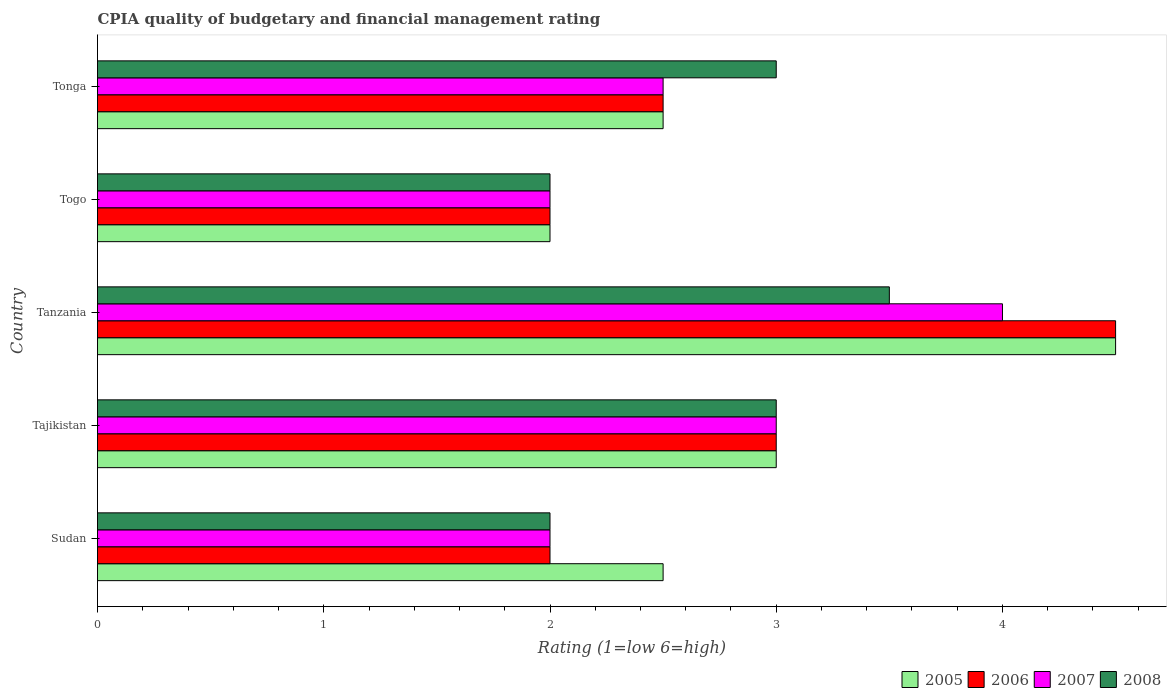How many different coloured bars are there?
Provide a succinct answer. 4. How many groups of bars are there?
Provide a short and direct response. 5. Are the number of bars on each tick of the Y-axis equal?
Provide a short and direct response. Yes. How many bars are there on the 4th tick from the bottom?
Offer a terse response. 4. What is the label of the 4th group of bars from the top?
Offer a terse response. Tajikistan. In how many cases, is the number of bars for a given country not equal to the number of legend labels?
Provide a succinct answer. 0. Across all countries, what is the maximum CPIA rating in 2005?
Your answer should be compact. 4.5. In which country was the CPIA rating in 2006 maximum?
Keep it short and to the point. Tanzania. In which country was the CPIA rating in 2005 minimum?
Ensure brevity in your answer.  Togo. What is the difference between the CPIA rating in 2005 in Sudan and that in Tanzania?
Ensure brevity in your answer.  -2. What is the difference between the CPIA rating in 2008 in Togo and the CPIA rating in 2006 in Tonga?
Ensure brevity in your answer.  -0.5. What is the difference between the CPIA rating in 2008 and CPIA rating in 2005 in Tonga?
Provide a short and direct response. 0.5. Is the CPIA rating in 2006 in Togo less than that in Tonga?
Give a very brief answer. Yes. Is the difference between the CPIA rating in 2008 in Sudan and Tajikistan greater than the difference between the CPIA rating in 2005 in Sudan and Tajikistan?
Your answer should be compact. No. In how many countries, is the CPIA rating in 2005 greater than the average CPIA rating in 2005 taken over all countries?
Offer a terse response. 2. Is the sum of the CPIA rating in 2005 in Tajikistan and Tonga greater than the maximum CPIA rating in 2006 across all countries?
Offer a terse response. Yes. Is it the case that in every country, the sum of the CPIA rating in 2005 and CPIA rating in 2008 is greater than the sum of CPIA rating in 2007 and CPIA rating in 2006?
Provide a succinct answer. No. Is it the case that in every country, the sum of the CPIA rating in 2007 and CPIA rating in 2005 is greater than the CPIA rating in 2008?
Offer a very short reply. Yes. How many countries are there in the graph?
Your answer should be very brief. 5. Does the graph contain grids?
Provide a short and direct response. No. Where does the legend appear in the graph?
Make the answer very short. Bottom right. How are the legend labels stacked?
Ensure brevity in your answer.  Horizontal. What is the title of the graph?
Make the answer very short. CPIA quality of budgetary and financial management rating. What is the label or title of the X-axis?
Ensure brevity in your answer.  Rating (1=low 6=high). What is the Rating (1=low 6=high) in 2005 in Sudan?
Provide a short and direct response. 2.5. What is the Rating (1=low 6=high) of 2006 in Sudan?
Your answer should be very brief. 2. What is the Rating (1=low 6=high) of 2007 in Sudan?
Offer a very short reply. 2. What is the Rating (1=low 6=high) in 2008 in Sudan?
Offer a terse response. 2. What is the Rating (1=low 6=high) of 2008 in Tanzania?
Give a very brief answer. 3.5. What is the Rating (1=low 6=high) in 2006 in Togo?
Offer a terse response. 2. What is the Rating (1=low 6=high) of 2008 in Togo?
Offer a terse response. 2. What is the Rating (1=low 6=high) in 2006 in Tonga?
Provide a succinct answer. 2.5. What is the Rating (1=low 6=high) of 2007 in Tonga?
Offer a terse response. 2.5. Across all countries, what is the maximum Rating (1=low 6=high) in 2007?
Offer a very short reply. 4. Across all countries, what is the maximum Rating (1=low 6=high) in 2008?
Ensure brevity in your answer.  3.5. Across all countries, what is the minimum Rating (1=low 6=high) in 2006?
Provide a short and direct response. 2. Across all countries, what is the minimum Rating (1=low 6=high) of 2007?
Your response must be concise. 2. What is the total Rating (1=low 6=high) of 2006 in the graph?
Give a very brief answer. 14. What is the total Rating (1=low 6=high) of 2008 in the graph?
Offer a very short reply. 13.5. What is the difference between the Rating (1=low 6=high) in 2005 in Sudan and that in Tajikistan?
Keep it short and to the point. -0.5. What is the difference between the Rating (1=low 6=high) of 2006 in Sudan and that in Tajikistan?
Give a very brief answer. -1. What is the difference between the Rating (1=low 6=high) of 2007 in Sudan and that in Tajikistan?
Your answer should be very brief. -1. What is the difference between the Rating (1=low 6=high) in 2006 in Sudan and that in Tanzania?
Offer a terse response. -2.5. What is the difference between the Rating (1=low 6=high) in 2005 in Sudan and that in Togo?
Give a very brief answer. 0.5. What is the difference between the Rating (1=low 6=high) in 2006 in Sudan and that in Togo?
Ensure brevity in your answer.  0. What is the difference between the Rating (1=low 6=high) in 2008 in Sudan and that in Togo?
Your answer should be very brief. 0. What is the difference between the Rating (1=low 6=high) of 2007 in Sudan and that in Tonga?
Offer a very short reply. -0.5. What is the difference between the Rating (1=low 6=high) in 2008 in Sudan and that in Tonga?
Give a very brief answer. -1. What is the difference between the Rating (1=low 6=high) of 2005 in Tajikistan and that in Tanzania?
Provide a succinct answer. -1.5. What is the difference between the Rating (1=low 6=high) of 2006 in Tajikistan and that in Tanzania?
Provide a succinct answer. -1.5. What is the difference between the Rating (1=low 6=high) in 2007 in Tajikistan and that in Tanzania?
Ensure brevity in your answer.  -1. What is the difference between the Rating (1=low 6=high) in 2005 in Tajikistan and that in Togo?
Your answer should be very brief. 1. What is the difference between the Rating (1=low 6=high) in 2006 in Tajikistan and that in Togo?
Your response must be concise. 1. What is the difference between the Rating (1=low 6=high) of 2008 in Tajikistan and that in Togo?
Give a very brief answer. 1. What is the difference between the Rating (1=low 6=high) in 2007 in Tajikistan and that in Tonga?
Provide a short and direct response. 0.5. What is the difference between the Rating (1=low 6=high) of 2007 in Tanzania and that in Togo?
Your answer should be compact. 2. What is the difference between the Rating (1=low 6=high) of 2008 in Tanzania and that in Togo?
Give a very brief answer. 1.5. What is the difference between the Rating (1=low 6=high) of 2006 in Tanzania and that in Tonga?
Your response must be concise. 2. What is the difference between the Rating (1=low 6=high) in 2005 in Togo and that in Tonga?
Keep it short and to the point. -0.5. What is the difference between the Rating (1=low 6=high) in 2008 in Togo and that in Tonga?
Make the answer very short. -1. What is the difference between the Rating (1=low 6=high) in 2005 in Sudan and the Rating (1=low 6=high) in 2008 in Tajikistan?
Offer a terse response. -0.5. What is the difference between the Rating (1=low 6=high) of 2006 in Sudan and the Rating (1=low 6=high) of 2007 in Tajikistan?
Keep it short and to the point. -1. What is the difference between the Rating (1=low 6=high) in 2006 in Sudan and the Rating (1=low 6=high) in 2008 in Tajikistan?
Provide a short and direct response. -1. What is the difference between the Rating (1=low 6=high) in 2007 in Sudan and the Rating (1=low 6=high) in 2008 in Tajikistan?
Keep it short and to the point. -1. What is the difference between the Rating (1=low 6=high) of 2005 in Sudan and the Rating (1=low 6=high) of 2006 in Tanzania?
Your answer should be compact. -2. What is the difference between the Rating (1=low 6=high) in 2006 in Sudan and the Rating (1=low 6=high) in 2008 in Tanzania?
Give a very brief answer. -1.5. What is the difference between the Rating (1=low 6=high) in 2007 in Sudan and the Rating (1=low 6=high) in 2008 in Tanzania?
Make the answer very short. -1.5. What is the difference between the Rating (1=low 6=high) in 2005 in Sudan and the Rating (1=low 6=high) in 2006 in Togo?
Provide a succinct answer. 0.5. What is the difference between the Rating (1=low 6=high) of 2005 in Sudan and the Rating (1=low 6=high) of 2007 in Togo?
Provide a succinct answer. 0.5. What is the difference between the Rating (1=low 6=high) of 2006 in Sudan and the Rating (1=low 6=high) of 2008 in Togo?
Your response must be concise. 0. What is the difference between the Rating (1=low 6=high) of 2005 in Sudan and the Rating (1=low 6=high) of 2007 in Tonga?
Your answer should be very brief. 0. What is the difference between the Rating (1=low 6=high) in 2007 in Sudan and the Rating (1=low 6=high) in 2008 in Tonga?
Make the answer very short. -1. What is the difference between the Rating (1=low 6=high) in 2005 in Tajikistan and the Rating (1=low 6=high) in 2007 in Tanzania?
Provide a short and direct response. -1. What is the difference between the Rating (1=low 6=high) of 2005 in Tajikistan and the Rating (1=low 6=high) of 2008 in Tanzania?
Offer a terse response. -0.5. What is the difference between the Rating (1=low 6=high) of 2007 in Tajikistan and the Rating (1=low 6=high) of 2008 in Tanzania?
Your answer should be very brief. -0.5. What is the difference between the Rating (1=low 6=high) in 2005 in Tajikistan and the Rating (1=low 6=high) in 2006 in Togo?
Ensure brevity in your answer.  1. What is the difference between the Rating (1=low 6=high) of 2005 in Tajikistan and the Rating (1=low 6=high) of 2007 in Togo?
Keep it short and to the point. 1. What is the difference between the Rating (1=low 6=high) in 2006 in Tajikistan and the Rating (1=low 6=high) in 2008 in Togo?
Your answer should be compact. 1. What is the difference between the Rating (1=low 6=high) in 2007 in Tajikistan and the Rating (1=low 6=high) in 2008 in Togo?
Give a very brief answer. 1. What is the difference between the Rating (1=low 6=high) of 2005 in Tajikistan and the Rating (1=low 6=high) of 2006 in Tonga?
Ensure brevity in your answer.  0.5. What is the difference between the Rating (1=low 6=high) in 2006 in Tajikistan and the Rating (1=low 6=high) in 2008 in Tonga?
Make the answer very short. 0. What is the difference between the Rating (1=low 6=high) of 2005 in Tanzania and the Rating (1=low 6=high) of 2007 in Togo?
Make the answer very short. 2.5. What is the difference between the Rating (1=low 6=high) of 2005 in Tanzania and the Rating (1=low 6=high) of 2008 in Togo?
Offer a very short reply. 2.5. What is the difference between the Rating (1=low 6=high) in 2006 in Tanzania and the Rating (1=low 6=high) in 2007 in Togo?
Your answer should be very brief. 2.5. What is the difference between the Rating (1=low 6=high) in 2005 in Tanzania and the Rating (1=low 6=high) in 2006 in Tonga?
Make the answer very short. 2. What is the difference between the Rating (1=low 6=high) of 2005 in Tanzania and the Rating (1=low 6=high) of 2007 in Tonga?
Ensure brevity in your answer.  2. What is the difference between the Rating (1=low 6=high) in 2005 in Tanzania and the Rating (1=low 6=high) in 2008 in Tonga?
Provide a short and direct response. 1.5. What is the difference between the Rating (1=low 6=high) of 2005 in Togo and the Rating (1=low 6=high) of 2007 in Tonga?
Offer a very short reply. -0.5. What is the difference between the Rating (1=low 6=high) in 2007 in Togo and the Rating (1=low 6=high) in 2008 in Tonga?
Your response must be concise. -1. What is the average Rating (1=low 6=high) in 2006 per country?
Ensure brevity in your answer.  2.8. What is the average Rating (1=low 6=high) in 2007 per country?
Make the answer very short. 2.7. What is the difference between the Rating (1=low 6=high) in 2006 and Rating (1=low 6=high) in 2007 in Sudan?
Offer a terse response. 0. What is the difference between the Rating (1=low 6=high) in 2006 and Rating (1=low 6=high) in 2008 in Sudan?
Provide a short and direct response. 0. What is the difference between the Rating (1=low 6=high) in 2007 and Rating (1=low 6=high) in 2008 in Sudan?
Ensure brevity in your answer.  0. What is the difference between the Rating (1=low 6=high) in 2005 and Rating (1=low 6=high) in 2006 in Tanzania?
Provide a succinct answer. 0. What is the difference between the Rating (1=low 6=high) of 2006 and Rating (1=low 6=high) of 2008 in Tanzania?
Your answer should be compact. 1. What is the difference between the Rating (1=low 6=high) of 2007 and Rating (1=low 6=high) of 2008 in Tanzania?
Make the answer very short. 0.5. What is the difference between the Rating (1=low 6=high) in 2005 and Rating (1=low 6=high) in 2006 in Togo?
Your response must be concise. 0. What is the difference between the Rating (1=low 6=high) in 2005 and Rating (1=low 6=high) in 2008 in Togo?
Your answer should be very brief. 0. What is the difference between the Rating (1=low 6=high) in 2006 and Rating (1=low 6=high) in 2007 in Togo?
Your answer should be compact. 0. What is the difference between the Rating (1=low 6=high) of 2005 and Rating (1=low 6=high) of 2006 in Tonga?
Offer a terse response. 0. What is the difference between the Rating (1=low 6=high) of 2006 and Rating (1=low 6=high) of 2007 in Tonga?
Give a very brief answer. 0. What is the difference between the Rating (1=low 6=high) of 2007 and Rating (1=low 6=high) of 2008 in Tonga?
Your answer should be compact. -0.5. What is the ratio of the Rating (1=low 6=high) in 2007 in Sudan to that in Tajikistan?
Make the answer very short. 0.67. What is the ratio of the Rating (1=low 6=high) in 2008 in Sudan to that in Tajikistan?
Offer a very short reply. 0.67. What is the ratio of the Rating (1=low 6=high) of 2005 in Sudan to that in Tanzania?
Offer a very short reply. 0.56. What is the ratio of the Rating (1=low 6=high) of 2006 in Sudan to that in Tanzania?
Provide a succinct answer. 0.44. What is the ratio of the Rating (1=low 6=high) of 2008 in Sudan to that in Tanzania?
Provide a short and direct response. 0.57. What is the ratio of the Rating (1=low 6=high) in 2005 in Sudan to that in Togo?
Offer a terse response. 1.25. What is the ratio of the Rating (1=low 6=high) in 2007 in Sudan to that in Togo?
Make the answer very short. 1. What is the ratio of the Rating (1=low 6=high) of 2005 in Sudan to that in Tonga?
Your response must be concise. 1. What is the ratio of the Rating (1=low 6=high) in 2006 in Sudan to that in Tonga?
Provide a succinct answer. 0.8. What is the ratio of the Rating (1=low 6=high) in 2008 in Sudan to that in Tonga?
Make the answer very short. 0.67. What is the ratio of the Rating (1=low 6=high) of 2007 in Tajikistan to that in Tanzania?
Ensure brevity in your answer.  0.75. What is the ratio of the Rating (1=low 6=high) of 2005 in Tajikistan to that in Togo?
Keep it short and to the point. 1.5. What is the ratio of the Rating (1=low 6=high) in 2007 in Tajikistan to that in Togo?
Offer a very short reply. 1.5. What is the ratio of the Rating (1=low 6=high) of 2008 in Tajikistan to that in Togo?
Offer a very short reply. 1.5. What is the ratio of the Rating (1=low 6=high) of 2005 in Tajikistan to that in Tonga?
Keep it short and to the point. 1.2. What is the ratio of the Rating (1=low 6=high) in 2006 in Tajikistan to that in Tonga?
Your answer should be very brief. 1.2. What is the ratio of the Rating (1=low 6=high) of 2008 in Tajikistan to that in Tonga?
Provide a succinct answer. 1. What is the ratio of the Rating (1=low 6=high) of 2005 in Tanzania to that in Togo?
Provide a succinct answer. 2.25. What is the ratio of the Rating (1=low 6=high) of 2006 in Tanzania to that in Togo?
Your answer should be very brief. 2.25. What is the ratio of the Rating (1=low 6=high) in 2007 in Tanzania to that in Togo?
Give a very brief answer. 2. What is the ratio of the Rating (1=low 6=high) in 2008 in Tanzania to that in Togo?
Keep it short and to the point. 1.75. What is the ratio of the Rating (1=low 6=high) in 2005 in Tanzania to that in Tonga?
Offer a terse response. 1.8. What is the ratio of the Rating (1=low 6=high) of 2005 in Togo to that in Tonga?
Your response must be concise. 0.8. What is the ratio of the Rating (1=low 6=high) in 2006 in Togo to that in Tonga?
Offer a terse response. 0.8. What is the ratio of the Rating (1=low 6=high) of 2008 in Togo to that in Tonga?
Your answer should be compact. 0.67. What is the difference between the highest and the second highest Rating (1=low 6=high) of 2005?
Your response must be concise. 1.5. What is the difference between the highest and the second highest Rating (1=low 6=high) in 2006?
Offer a very short reply. 1.5. What is the difference between the highest and the second highest Rating (1=low 6=high) of 2008?
Your answer should be very brief. 0.5. What is the difference between the highest and the lowest Rating (1=low 6=high) of 2005?
Your answer should be very brief. 2.5. 